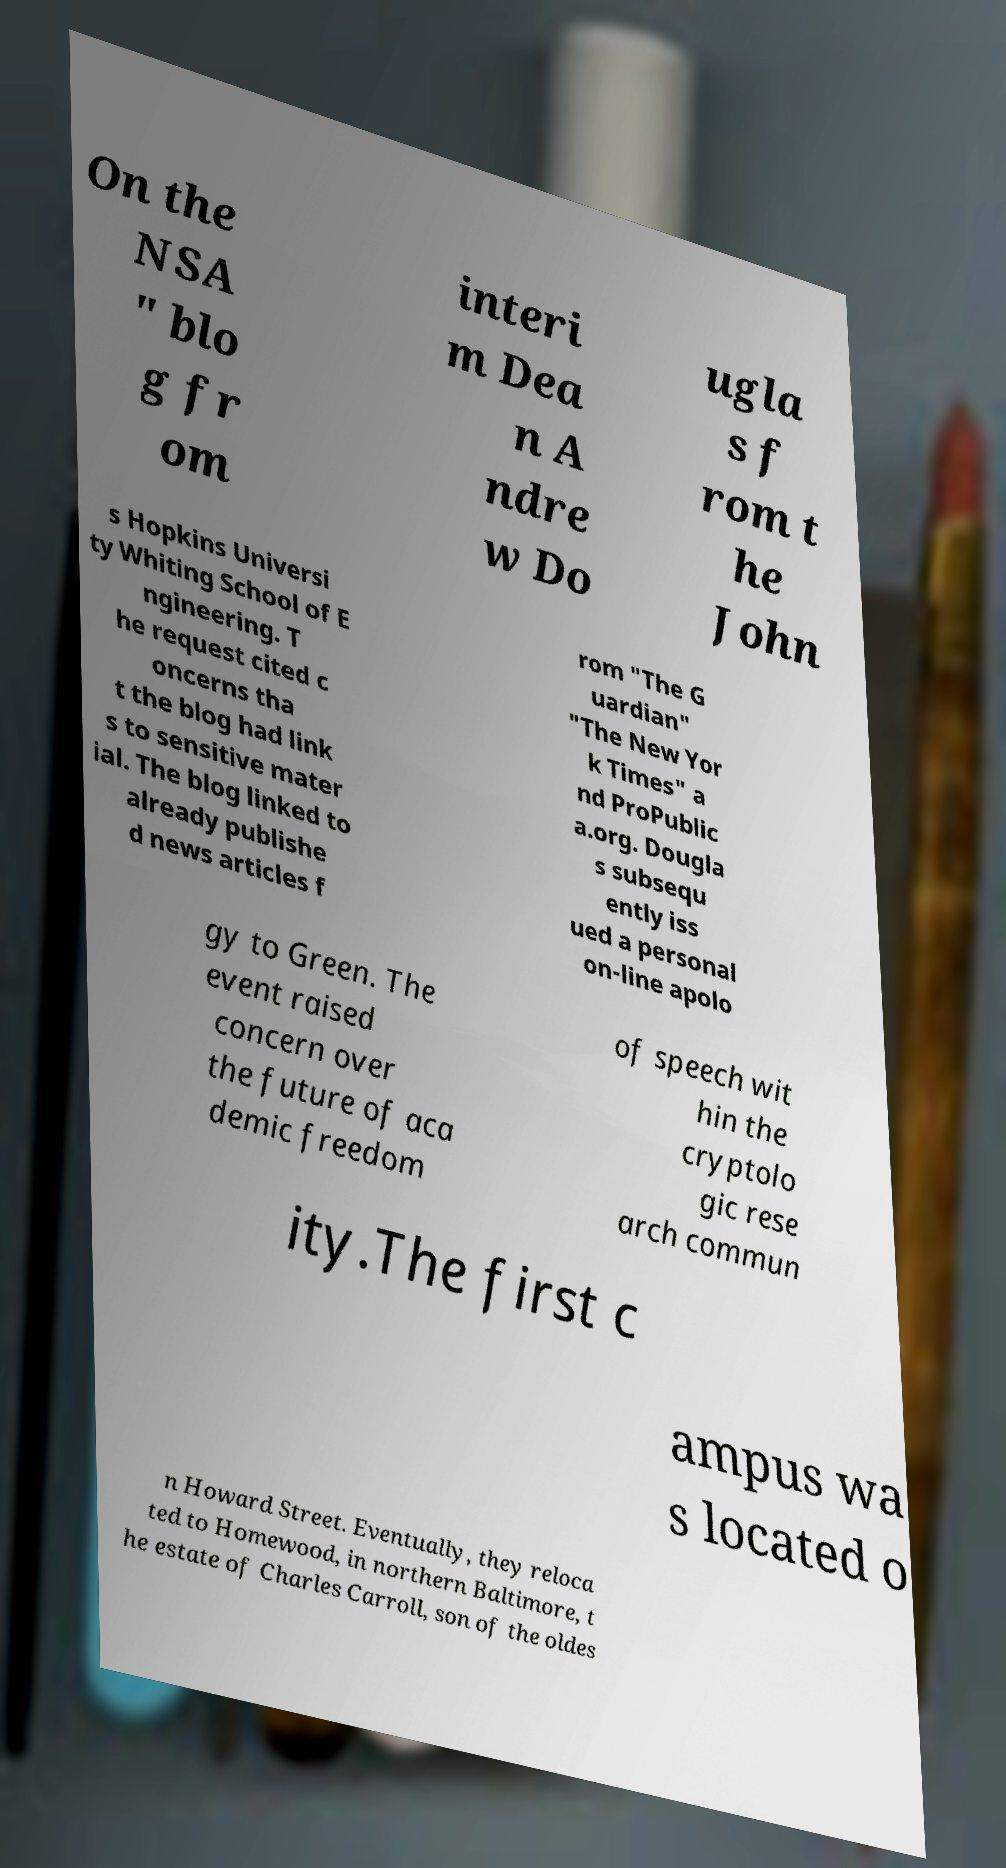What messages or text are displayed in this image? I need them in a readable, typed format. On the NSA " blo g fr om interi m Dea n A ndre w Do ugla s f rom t he John s Hopkins Universi ty Whiting School of E ngineering. T he request cited c oncerns tha t the blog had link s to sensitive mater ial. The blog linked to already publishe d news articles f rom "The G uardian" "The New Yor k Times" a nd ProPublic a.org. Dougla s subsequ ently iss ued a personal on-line apolo gy to Green. The event raised concern over the future of aca demic freedom of speech wit hin the cryptolo gic rese arch commun ity.The first c ampus wa s located o n Howard Street. Eventually, they reloca ted to Homewood, in northern Baltimore, t he estate of Charles Carroll, son of the oldes 